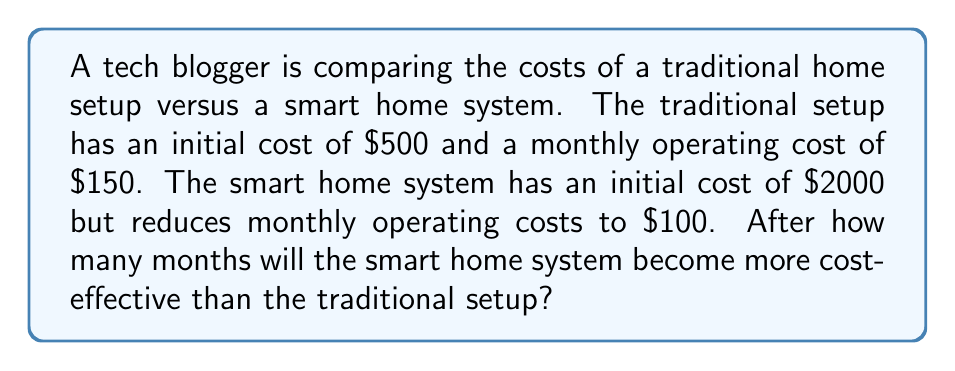What is the answer to this math problem? Let's approach this step-by-step using a system of equations:

1) Let $x$ be the number of months.

2) For the traditional setup, the total cost after $x$ months is:
   $$C_t = 500 + 150x$$

3) For the smart home system, the total cost after $x$ months is:
   $$C_s = 2000 + 100x$$

4) The break-even point occurs when these costs are equal:
   $$C_t = C_s$$
   $$500 + 150x = 2000 + 100x$$

5) Solving the equation:
   $$500 + 150x = 2000 + 100x$$
   $$150x - 100x = 2000 - 500$$
   $$50x = 1500$$
   $$x = 1500 / 50 = 30$$

Therefore, after 30 months, the smart home system becomes more cost-effective.

To verify:
- Traditional setup cost after 30 months: $500 + (150 * 30) = $5000
- Smart home system cost after 30 months: $2000 + (100 * 30) = $5000

After this point, the smart home system will be cheaper overall.
Answer: 30 months 